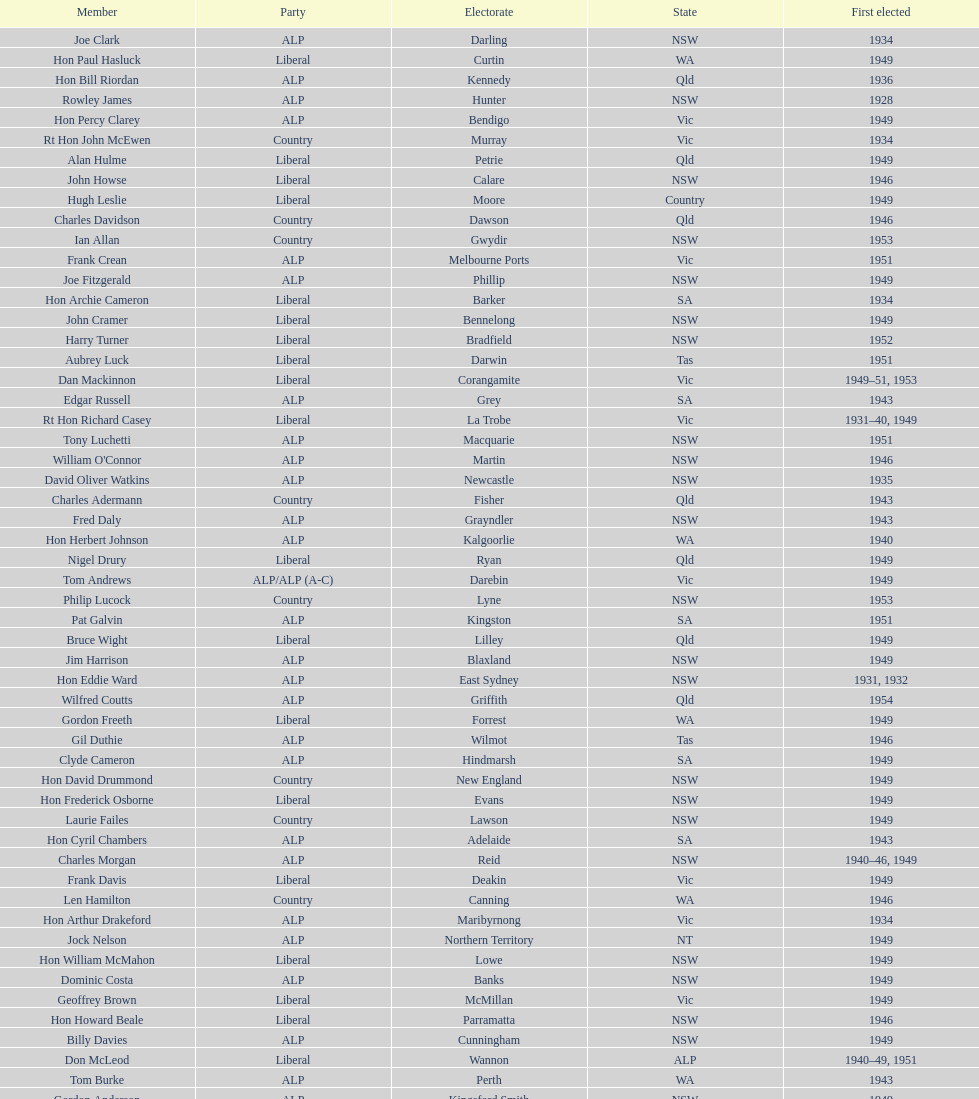After tom burke was elected, what was the next year where another tom would be elected? 1937. 